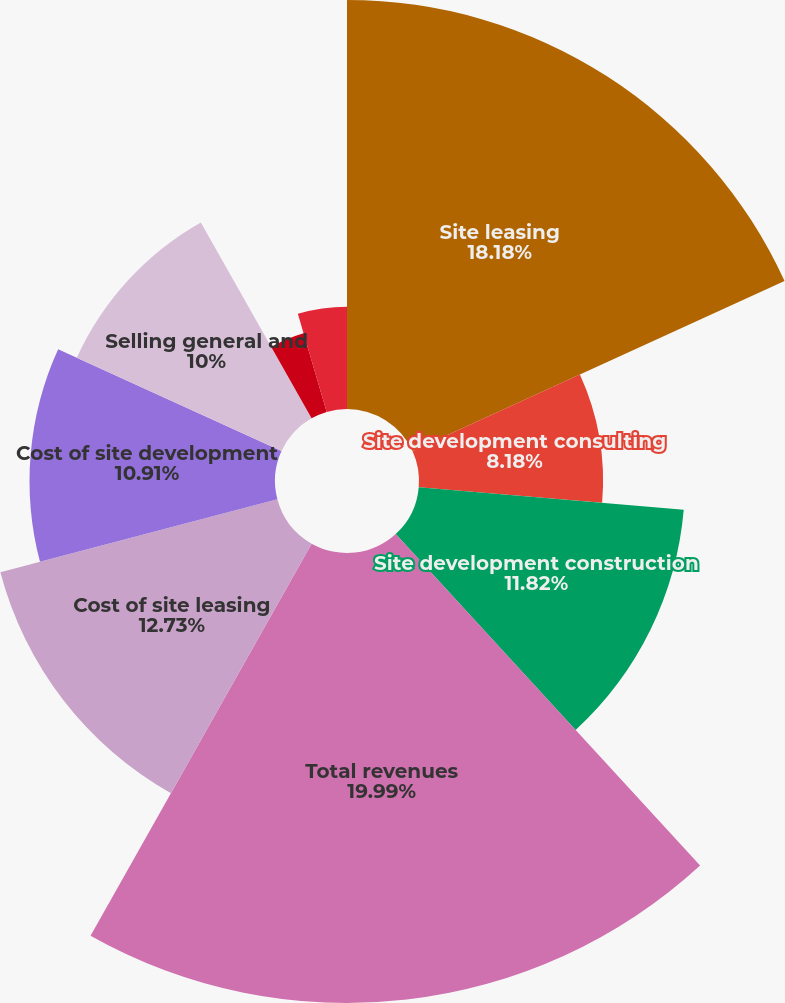<chart> <loc_0><loc_0><loc_500><loc_500><pie_chart><fcel>Site leasing<fcel>Site development consulting<fcel>Site development construction<fcel>Total revenues<fcel>Cost of site leasing<fcel>Cost of site development<fcel>Selling general and<fcel>Asset impairment<fcel>Acquisition related expenses<nl><fcel>18.18%<fcel>8.18%<fcel>11.82%<fcel>20.0%<fcel>12.73%<fcel>10.91%<fcel>10.0%<fcel>3.64%<fcel>4.55%<nl></chart> 